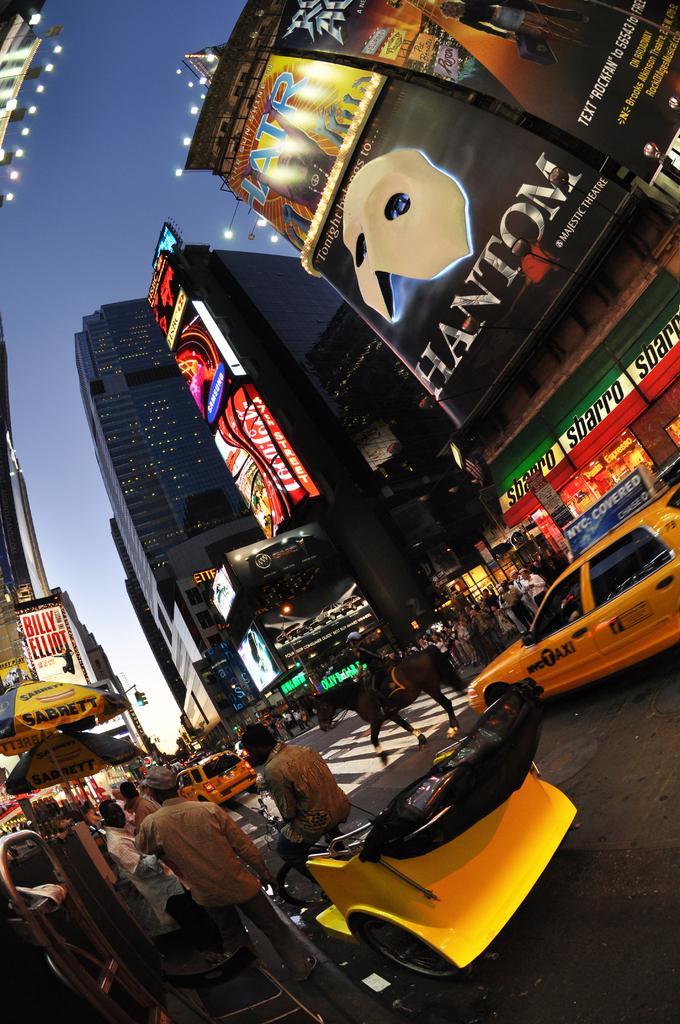Describe this image in one or two sentences. In this image we can see buildings. At the top of the image there is sky. At the bottom of the image there is road. There are vehicles on the road. There are people. There is a horse. 